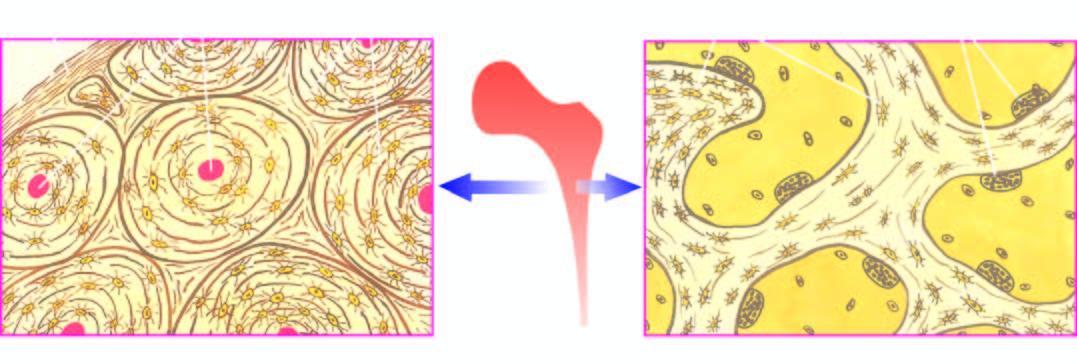does the trabecular bone forming the marrow space show trabeculae with osteoclastic activity at the margins?
Answer the question using a single word or phrase. Yes 